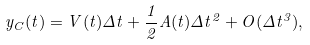<formula> <loc_0><loc_0><loc_500><loc_500>y _ { C } ( t ) = V ( t ) \Delta t + \frac { 1 } { 2 } A ( t ) \Delta t ^ { 2 } + O ( \Delta t ^ { 3 } ) ,</formula> 